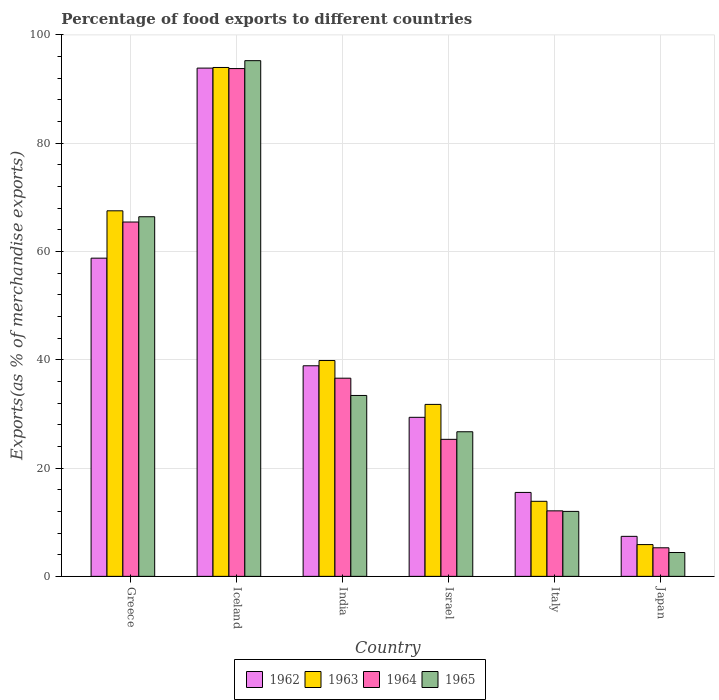How many different coloured bars are there?
Ensure brevity in your answer.  4. Are the number of bars per tick equal to the number of legend labels?
Your answer should be very brief. Yes. Are the number of bars on each tick of the X-axis equal?
Keep it short and to the point. Yes. How many bars are there on the 1st tick from the left?
Make the answer very short. 4. What is the percentage of exports to different countries in 1963 in Greece?
Make the answer very short. 67.52. Across all countries, what is the maximum percentage of exports to different countries in 1964?
Make the answer very short. 93.79. Across all countries, what is the minimum percentage of exports to different countries in 1963?
Make the answer very short. 5.87. In which country was the percentage of exports to different countries in 1962 maximum?
Provide a short and direct response. Iceland. What is the total percentage of exports to different countries in 1964 in the graph?
Provide a short and direct response. 238.53. What is the difference between the percentage of exports to different countries in 1962 in Italy and that in Japan?
Keep it short and to the point. 8.11. What is the difference between the percentage of exports to different countries in 1962 in Iceland and the percentage of exports to different countries in 1964 in Italy?
Your answer should be compact. 81.78. What is the average percentage of exports to different countries in 1962 per country?
Make the answer very short. 40.63. What is the difference between the percentage of exports to different countries of/in 1962 and percentage of exports to different countries of/in 1964 in Greece?
Provide a short and direct response. -6.67. What is the ratio of the percentage of exports to different countries in 1962 in Greece to that in Iceland?
Make the answer very short. 0.63. Is the percentage of exports to different countries in 1965 in Iceland less than that in India?
Offer a very short reply. No. Is the difference between the percentage of exports to different countries in 1962 in Greece and Japan greater than the difference between the percentage of exports to different countries in 1964 in Greece and Japan?
Make the answer very short. No. What is the difference between the highest and the second highest percentage of exports to different countries in 1964?
Give a very brief answer. 28.84. What is the difference between the highest and the lowest percentage of exports to different countries in 1962?
Provide a succinct answer. 86.49. In how many countries, is the percentage of exports to different countries in 1965 greater than the average percentage of exports to different countries in 1965 taken over all countries?
Your answer should be compact. 2. Is the sum of the percentage of exports to different countries in 1965 in Israel and Italy greater than the maximum percentage of exports to different countries in 1963 across all countries?
Offer a very short reply. No. Is it the case that in every country, the sum of the percentage of exports to different countries in 1964 and percentage of exports to different countries in 1962 is greater than the sum of percentage of exports to different countries in 1965 and percentage of exports to different countries in 1963?
Provide a succinct answer. No. What does the 3rd bar from the left in Iceland represents?
Make the answer very short. 1964. What does the 2nd bar from the right in Italy represents?
Your answer should be compact. 1964. Is it the case that in every country, the sum of the percentage of exports to different countries in 1965 and percentage of exports to different countries in 1964 is greater than the percentage of exports to different countries in 1962?
Make the answer very short. Yes. How many bars are there?
Your response must be concise. 24. Are all the bars in the graph horizontal?
Provide a short and direct response. No. How many countries are there in the graph?
Offer a very short reply. 6. Does the graph contain any zero values?
Offer a terse response. No. What is the title of the graph?
Give a very brief answer. Percentage of food exports to different countries. Does "2000" appear as one of the legend labels in the graph?
Ensure brevity in your answer.  No. What is the label or title of the Y-axis?
Your response must be concise. Exports(as % of merchandise exports). What is the Exports(as % of merchandise exports) in 1962 in Greece?
Keep it short and to the point. 58.77. What is the Exports(as % of merchandise exports) of 1963 in Greece?
Your response must be concise. 67.52. What is the Exports(as % of merchandise exports) in 1964 in Greece?
Provide a succinct answer. 65.45. What is the Exports(as % of merchandise exports) in 1965 in Greece?
Keep it short and to the point. 66.42. What is the Exports(as % of merchandise exports) of 1962 in Iceland?
Your response must be concise. 93.87. What is the Exports(as % of merchandise exports) of 1963 in Iceland?
Offer a very short reply. 93.99. What is the Exports(as % of merchandise exports) in 1964 in Iceland?
Offer a terse response. 93.79. What is the Exports(as % of merchandise exports) of 1965 in Iceland?
Keep it short and to the point. 95.25. What is the Exports(as % of merchandise exports) of 1962 in India?
Offer a very short reply. 38.9. What is the Exports(as % of merchandise exports) of 1963 in India?
Offer a terse response. 39.86. What is the Exports(as % of merchandise exports) of 1964 in India?
Give a very brief answer. 36.6. What is the Exports(as % of merchandise exports) of 1965 in India?
Give a very brief answer. 33.41. What is the Exports(as % of merchandise exports) in 1962 in Israel?
Make the answer very short. 29.37. What is the Exports(as % of merchandise exports) of 1963 in Israel?
Keep it short and to the point. 31.76. What is the Exports(as % of merchandise exports) in 1964 in Israel?
Offer a terse response. 25.31. What is the Exports(as % of merchandise exports) in 1965 in Israel?
Your answer should be compact. 26.71. What is the Exports(as % of merchandise exports) of 1962 in Italy?
Provide a succinct answer. 15.5. What is the Exports(as % of merchandise exports) in 1963 in Italy?
Make the answer very short. 13.86. What is the Exports(as % of merchandise exports) of 1964 in Italy?
Give a very brief answer. 12.1. What is the Exports(as % of merchandise exports) in 1965 in Italy?
Give a very brief answer. 12. What is the Exports(as % of merchandise exports) in 1962 in Japan?
Make the answer very short. 7.39. What is the Exports(as % of merchandise exports) in 1963 in Japan?
Provide a succinct answer. 5.87. What is the Exports(as % of merchandise exports) of 1964 in Japan?
Your response must be concise. 5.28. What is the Exports(as % of merchandise exports) of 1965 in Japan?
Provide a short and direct response. 4.41. Across all countries, what is the maximum Exports(as % of merchandise exports) in 1962?
Your answer should be compact. 93.87. Across all countries, what is the maximum Exports(as % of merchandise exports) in 1963?
Make the answer very short. 93.99. Across all countries, what is the maximum Exports(as % of merchandise exports) in 1964?
Offer a very short reply. 93.79. Across all countries, what is the maximum Exports(as % of merchandise exports) of 1965?
Your response must be concise. 95.25. Across all countries, what is the minimum Exports(as % of merchandise exports) in 1962?
Give a very brief answer. 7.39. Across all countries, what is the minimum Exports(as % of merchandise exports) of 1963?
Provide a short and direct response. 5.87. Across all countries, what is the minimum Exports(as % of merchandise exports) of 1964?
Your answer should be compact. 5.28. Across all countries, what is the minimum Exports(as % of merchandise exports) in 1965?
Your answer should be very brief. 4.41. What is the total Exports(as % of merchandise exports) in 1962 in the graph?
Keep it short and to the point. 243.81. What is the total Exports(as % of merchandise exports) in 1963 in the graph?
Keep it short and to the point. 252.87. What is the total Exports(as % of merchandise exports) of 1964 in the graph?
Your answer should be compact. 238.53. What is the total Exports(as % of merchandise exports) of 1965 in the graph?
Give a very brief answer. 238.2. What is the difference between the Exports(as % of merchandise exports) of 1962 in Greece and that in Iceland?
Offer a very short reply. -35.1. What is the difference between the Exports(as % of merchandise exports) in 1963 in Greece and that in Iceland?
Give a very brief answer. -26.47. What is the difference between the Exports(as % of merchandise exports) of 1964 in Greece and that in Iceland?
Offer a very short reply. -28.35. What is the difference between the Exports(as % of merchandise exports) of 1965 in Greece and that in Iceland?
Provide a short and direct response. -28.83. What is the difference between the Exports(as % of merchandise exports) of 1962 in Greece and that in India?
Provide a short and direct response. 19.87. What is the difference between the Exports(as % of merchandise exports) of 1963 in Greece and that in India?
Your response must be concise. 27.65. What is the difference between the Exports(as % of merchandise exports) in 1964 in Greece and that in India?
Offer a very short reply. 28.84. What is the difference between the Exports(as % of merchandise exports) of 1965 in Greece and that in India?
Give a very brief answer. 33.01. What is the difference between the Exports(as % of merchandise exports) in 1962 in Greece and that in Israel?
Your response must be concise. 29.4. What is the difference between the Exports(as % of merchandise exports) in 1963 in Greece and that in Israel?
Offer a terse response. 35.76. What is the difference between the Exports(as % of merchandise exports) in 1964 in Greece and that in Israel?
Give a very brief answer. 40.14. What is the difference between the Exports(as % of merchandise exports) of 1965 in Greece and that in Israel?
Make the answer very short. 39.71. What is the difference between the Exports(as % of merchandise exports) in 1962 in Greece and that in Italy?
Your response must be concise. 43.27. What is the difference between the Exports(as % of merchandise exports) in 1963 in Greece and that in Italy?
Keep it short and to the point. 53.65. What is the difference between the Exports(as % of merchandise exports) in 1964 in Greece and that in Italy?
Provide a succinct answer. 53.35. What is the difference between the Exports(as % of merchandise exports) in 1965 in Greece and that in Italy?
Your answer should be compact. 54.42. What is the difference between the Exports(as % of merchandise exports) in 1962 in Greece and that in Japan?
Provide a short and direct response. 51.38. What is the difference between the Exports(as % of merchandise exports) in 1963 in Greece and that in Japan?
Provide a short and direct response. 61.65. What is the difference between the Exports(as % of merchandise exports) in 1964 in Greece and that in Japan?
Offer a very short reply. 60.17. What is the difference between the Exports(as % of merchandise exports) in 1965 in Greece and that in Japan?
Provide a short and direct response. 62.01. What is the difference between the Exports(as % of merchandise exports) of 1962 in Iceland and that in India?
Keep it short and to the point. 54.98. What is the difference between the Exports(as % of merchandise exports) of 1963 in Iceland and that in India?
Offer a terse response. 54.13. What is the difference between the Exports(as % of merchandise exports) in 1964 in Iceland and that in India?
Your answer should be very brief. 57.19. What is the difference between the Exports(as % of merchandise exports) in 1965 in Iceland and that in India?
Provide a succinct answer. 61.84. What is the difference between the Exports(as % of merchandise exports) of 1962 in Iceland and that in Israel?
Provide a succinct answer. 64.5. What is the difference between the Exports(as % of merchandise exports) in 1963 in Iceland and that in Israel?
Give a very brief answer. 62.23. What is the difference between the Exports(as % of merchandise exports) of 1964 in Iceland and that in Israel?
Offer a terse response. 68.48. What is the difference between the Exports(as % of merchandise exports) of 1965 in Iceland and that in Israel?
Your answer should be compact. 68.54. What is the difference between the Exports(as % of merchandise exports) in 1962 in Iceland and that in Italy?
Your response must be concise. 78.37. What is the difference between the Exports(as % of merchandise exports) in 1963 in Iceland and that in Italy?
Offer a very short reply. 80.13. What is the difference between the Exports(as % of merchandise exports) in 1964 in Iceland and that in Italy?
Offer a terse response. 81.69. What is the difference between the Exports(as % of merchandise exports) in 1965 in Iceland and that in Italy?
Your answer should be compact. 83.25. What is the difference between the Exports(as % of merchandise exports) of 1962 in Iceland and that in Japan?
Give a very brief answer. 86.49. What is the difference between the Exports(as % of merchandise exports) in 1963 in Iceland and that in Japan?
Make the answer very short. 88.12. What is the difference between the Exports(as % of merchandise exports) in 1964 in Iceland and that in Japan?
Your answer should be very brief. 88.51. What is the difference between the Exports(as % of merchandise exports) of 1965 in Iceland and that in Japan?
Your response must be concise. 90.84. What is the difference between the Exports(as % of merchandise exports) in 1962 in India and that in Israel?
Offer a terse response. 9.52. What is the difference between the Exports(as % of merchandise exports) in 1963 in India and that in Israel?
Ensure brevity in your answer.  8.1. What is the difference between the Exports(as % of merchandise exports) of 1964 in India and that in Israel?
Ensure brevity in your answer.  11.29. What is the difference between the Exports(as % of merchandise exports) in 1965 in India and that in Israel?
Your answer should be compact. 6.71. What is the difference between the Exports(as % of merchandise exports) of 1962 in India and that in Italy?
Your answer should be very brief. 23.39. What is the difference between the Exports(as % of merchandise exports) in 1963 in India and that in Italy?
Make the answer very short. 26. What is the difference between the Exports(as % of merchandise exports) of 1964 in India and that in Italy?
Make the answer very short. 24.5. What is the difference between the Exports(as % of merchandise exports) in 1965 in India and that in Italy?
Make the answer very short. 21.41. What is the difference between the Exports(as % of merchandise exports) in 1962 in India and that in Japan?
Keep it short and to the point. 31.51. What is the difference between the Exports(as % of merchandise exports) in 1963 in India and that in Japan?
Provide a short and direct response. 34. What is the difference between the Exports(as % of merchandise exports) of 1964 in India and that in Japan?
Make the answer very short. 31.32. What is the difference between the Exports(as % of merchandise exports) in 1965 in India and that in Japan?
Give a very brief answer. 29.01. What is the difference between the Exports(as % of merchandise exports) of 1962 in Israel and that in Italy?
Provide a short and direct response. 13.87. What is the difference between the Exports(as % of merchandise exports) of 1963 in Israel and that in Italy?
Keep it short and to the point. 17.9. What is the difference between the Exports(as % of merchandise exports) of 1964 in Israel and that in Italy?
Give a very brief answer. 13.21. What is the difference between the Exports(as % of merchandise exports) of 1965 in Israel and that in Italy?
Give a very brief answer. 14.71. What is the difference between the Exports(as % of merchandise exports) of 1962 in Israel and that in Japan?
Keep it short and to the point. 21.98. What is the difference between the Exports(as % of merchandise exports) of 1963 in Israel and that in Japan?
Your response must be concise. 25.89. What is the difference between the Exports(as % of merchandise exports) of 1964 in Israel and that in Japan?
Ensure brevity in your answer.  20.03. What is the difference between the Exports(as % of merchandise exports) of 1965 in Israel and that in Japan?
Offer a very short reply. 22.3. What is the difference between the Exports(as % of merchandise exports) in 1962 in Italy and that in Japan?
Keep it short and to the point. 8.11. What is the difference between the Exports(as % of merchandise exports) of 1963 in Italy and that in Japan?
Make the answer very short. 8. What is the difference between the Exports(as % of merchandise exports) of 1964 in Italy and that in Japan?
Your response must be concise. 6.82. What is the difference between the Exports(as % of merchandise exports) of 1965 in Italy and that in Japan?
Provide a succinct answer. 7.59. What is the difference between the Exports(as % of merchandise exports) in 1962 in Greece and the Exports(as % of merchandise exports) in 1963 in Iceland?
Keep it short and to the point. -35.22. What is the difference between the Exports(as % of merchandise exports) of 1962 in Greece and the Exports(as % of merchandise exports) of 1964 in Iceland?
Your response must be concise. -35.02. What is the difference between the Exports(as % of merchandise exports) of 1962 in Greece and the Exports(as % of merchandise exports) of 1965 in Iceland?
Give a very brief answer. -36.48. What is the difference between the Exports(as % of merchandise exports) in 1963 in Greece and the Exports(as % of merchandise exports) in 1964 in Iceland?
Make the answer very short. -26.27. What is the difference between the Exports(as % of merchandise exports) of 1963 in Greece and the Exports(as % of merchandise exports) of 1965 in Iceland?
Make the answer very short. -27.73. What is the difference between the Exports(as % of merchandise exports) of 1964 in Greece and the Exports(as % of merchandise exports) of 1965 in Iceland?
Make the answer very short. -29.8. What is the difference between the Exports(as % of merchandise exports) in 1962 in Greece and the Exports(as % of merchandise exports) in 1963 in India?
Offer a very short reply. 18.91. What is the difference between the Exports(as % of merchandise exports) of 1962 in Greece and the Exports(as % of merchandise exports) of 1964 in India?
Provide a succinct answer. 22.17. What is the difference between the Exports(as % of merchandise exports) in 1962 in Greece and the Exports(as % of merchandise exports) in 1965 in India?
Your response must be concise. 25.36. What is the difference between the Exports(as % of merchandise exports) of 1963 in Greece and the Exports(as % of merchandise exports) of 1964 in India?
Keep it short and to the point. 30.92. What is the difference between the Exports(as % of merchandise exports) of 1963 in Greece and the Exports(as % of merchandise exports) of 1965 in India?
Your answer should be very brief. 34.1. What is the difference between the Exports(as % of merchandise exports) of 1964 in Greece and the Exports(as % of merchandise exports) of 1965 in India?
Your response must be concise. 32.03. What is the difference between the Exports(as % of merchandise exports) in 1962 in Greece and the Exports(as % of merchandise exports) in 1963 in Israel?
Provide a succinct answer. 27.01. What is the difference between the Exports(as % of merchandise exports) of 1962 in Greece and the Exports(as % of merchandise exports) of 1964 in Israel?
Provide a succinct answer. 33.46. What is the difference between the Exports(as % of merchandise exports) of 1962 in Greece and the Exports(as % of merchandise exports) of 1965 in Israel?
Keep it short and to the point. 32.06. What is the difference between the Exports(as % of merchandise exports) in 1963 in Greece and the Exports(as % of merchandise exports) in 1964 in Israel?
Ensure brevity in your answer.  42.21. What is the difference between the Exports(as % of merchandise exports) of 1963 in Greece and the Exports(as % of merchandise exports) of 1965 in Israel?
Make the answer very short. 40.81. What is the difference between the Exports(as % of merchandise exports) of 1964 in Greece and the Exports(as % of merchandise exports) of 1965 in Israel?
Provide a succinct answer. 38.74. What is the difference between the Exports(as % of merchandise exports) in 1962 in Greece and the Exports(as % of merchandise exports) in 1963 in Italy?
Make the answer very short. 44.91. What is the difference between the Exports(as % of merchandise exports) of 1962 in Greece and the Exports(as % of merchandise exports) of 1964 in Italy?
Ensure brevity in your answer.  46.67. What is the difference between the Exports(as % of merchandise exports) of 1962 in Greece and the Exports(as % of merchandise exports) of 1965 in Italy?
Make the answer very short. 46.77. What is the difference between the Exports(as % of merchandise exports) of 1963 in Greece and the Exports(as % of merchandise exports) of 1964 in Italy?
Offer a terse response. 55.42. What is the difference between the Exports(as % of merchandise exports) of 1963 in Greece and the Exports(as % of merchandise exports) of 1965 in Italy?
Your answer should be very brief. 55.52. What is the difference between the Exports(as % of merchandise exports) in 1964 in Greece and the Exports(as % of merchandise exports) in 1965 in Italy?
Your answer should be very brief. 53.45. What is the difference between the Exports(as % of merchandise exports) in 1962 in Greece and the Exports(as % of merchandise exports) in 1963 in Japan?
Make the answer very short. 52.9. What is the difference between the Exports(as % of merchandise exports) of 1962 in Greece and the Exports(as % of merchandise exports) of 1964 in Japan?
Offer a terse response. 53.49. What is the difference between the Exports(as % of merchandise exports) in 1962 in Greece and the Exports(as % of merchandise exports) in 1965 in Japan?
Give a very brief answer. 54.36. What is the difference between the Exports(as % of merchandise exports) in 1963 in Greece and the Exports(as % of merchandise exports) in 1964 in Japan?
Ensure brevity in your answer.  62.24. What is the difference between the Exports(as % of merchandise exports) in 1963 in Greece and the Exports(as % of merchandise exports) in 1965 in Japan?
Offer a very short reply. 63.11. What is the difference between the Exports(as % of merchandise exports) of 1964 in Greece and the Exports(as % of merchandise exports) of 1965 in Japan?
Ensure brevity in your answer.  61.04. What is the difference between the Exports(as % of merchandise exports) of 1962 in Iceland and the Exports(as % of merchandise exports) of 1963 in India?
Give a very brief answer. 54.01. What is the difference between the Exports(as % of merchandise exports) in 1962 in Iceland and the Exports(as % of merchandise exports) in 1964 in India?
Offer a terse response. 57.27. What is the difference between the Exports(as % of merchandise exports) in 1962 in Iceland and the Exports(as % of merchandise exports) in 1965 in India?
Your response must be concise. 60.46. What is the difference between the Exports(as % of merchandise exports) of 1963 in Iceland and the Exports(as % of merchandise exports) of 1964 in India?
Provide a succinct answer. 57.39. What is the difference between the Exports(as % of merchandise exports) in 1963 in Iceland and the Exports(as % of merchandise exports) in 1965 in India?
Keep it short and to the point. 60.58. What is the difference between the Exports(as % of merchandise exports) of 1964 in Iceland and the Exports(as % of merchandise exports) of 1965 in India?
Ensure brevity in your answer.  60.38. What is the difference between the Exports(as % of merchandise exports) in 1962 in Iceland and the Exports(as % of merchandise exports) in 1963 in Israel?
Offer a very short reply. 62.11. What is the difference between the Exports(as % of merchandise exports) in 1962 in Iceland and the Exports(as % of merchandise exports) in 1964 in Israel?
Ensure brevity in your answer.  68.57. What is the difference between the Exports(as % of merchandise exports) in 1962 in Iceland and the Exports(as % of merchandise exports) in 1965 in Israel?
Provide a succinct answer. 67.17. What is the difference between the Exports(as % of merchandise exports) of 1963 in Iceland and the Exports(as % of merchandise exports) of 1964 in Israel?
Your response must be concise. 68.68. What is the difference between the Exports(as % of merchandise exports) of 1963 in Iceland and the Exports(as % of merchandise exports) of 1965 in Israel?
Your answer should be compact. 67.28. What is the difference between the Exports(as % of merchandise exports) of 1964 in Iceland and the Exports(as % of merchandise exports) of 1965 in Israel?
Give a very brief answer. 67.08. What is the difference between the Exports(as % of merchandise exports) in 1962 in Iceland and the Exports(as % of merchandise exports) in 1963 in Italy?
Offer a very short reply. 80.01. What is the difference between the Exports(as % of merchandise exports) of 1962 in Iceland and the Exports(as % of merchandise exports) of 1964 in Italy?
Give a very brief answer. 81.78. What is the difference between the Exports(as % of merchandise exports) of 1962 in Iceland and the Exports(as % of merchandise exports) of 1965 in Italy?
Make the answer very short. 81.88. What is the difference between the Exports(as % of merchandise exports) of 1963 in Iceland and the Exports(as % of merchandise exports) of 1964 in Italy?
Ensure brevity in your answer.  81.89. What is the difference between the Exports(as % of merchandise exports) in 1963 in Iceland and the Exports(as % of merchandise exports) in 1965 in Italy?
Your answer should be compact. 81.99. What is the difference between the Exports(as % of merchandise exports) of 1964 in Iceland and the Exports(as % of merchandise exports) of 1965 in Italy?
Offer a terse response. 81.79. What is the difference between the Exports(as % of merchandise exports) in 1962 in Iceland and the Exports(as % of merchandise exports) in 1963 in Japan?
Provide a succinct answer. 88.01. What is the difference between the Exports(as % of merchandise exports) in 1962 in Iceland and the Exports(as % of merchandise exports) in 1964 in Japan?
Provide a short and direct response. 88.6. What is the difference between the Exports(as % of merchandise exports) of 1962 in Iceland and the Exports(as % of merchandise exports) of 1965 in Japan?
Keep it short and to the point. 89.47. What is the difference between the Exports(as % of merchandise exports) in 1963 in Iceland and the Exports(as % of merchandise exports) in 1964 in Japan?
Your answer should be very brief. 88.71. What is the difference between the Exports(as % of merchandise exports) in 1963 in Iceland and the Exports(as % of merchandise exports) in 1965 in Japan?
Provide a succinct answer. 89.58. What is the difference between the Exports(as % of merchandise exports) of 1964 in Iceland and the Exports(as % of merchandise exports) of 1965 in Japan?
Your answer should be compact. 89.38. What is the difference between the Exports(as % of merchandise exports) of 1962 in India and the Exports(as % of merchandise exports) of 1963 in Israel?
Offer a terse response. 7.14. What is the difference between the Exports(as % of merchandise exports) in 1962 in India and the Exports(as % of merchandise exports) in 1964 in Israel?
Provide a succinct answer. 13.59. What is the difference between the Exports(as % of merchandise exports) in 1962 in India and the Exports(as % of merchandise exports) in 1965 in Israel?
Ensure brevity in your answer.  12.19. What is the difference between the Exports(as % of merchandise exports) in 1963 in India and the Exports(as % of merchandise exports) in 1964 in Israel?
Keep it short and to the point. 14.56. What is the difference between the Exports(as % of merchandise exports) of 1963 in India and the Exports(as % of merchandise exports) of 1965 in Israel?
Offer a terse response. 13.16. What is the difference between the Exports(as % of merchandise exports) of 1964 in India and the Exports(as % of merchandise exports) of 1965 in Israel?
Offer a terse response. 9.89. What is the difference between the Exports(as % of merchandise exports) of 1962 in India and the Exports(as % of merchandise exports) of 1963 in Italy?
Ensure brevity in your answer.  25.03. What is the difference between the Exports(as % of merchandise exports) of 1962 in India and the Exports(as % of merchandise exports) of 1964 in Italy?
Keep it short and to the point. 26.8. What is the difference between the Exports(as % of merchandise exports) in 1962 in India and the Exports(as % of merchandise exports) in 1965 in Italy?
Offer a terse response. 26.9. What is the difference between the Exports(as % of merchandise exports) of 1963 in India and the Exports(as % of merchandise exports) of 1964 in Italy?
Offer a terse response. 27.77. What is the difference between the Exports(as % of merchandise exports) of 1963 in India and the Exports(as % of merchandise exports) of 1965 in Italy?
Make the answer very short. 27.87. What is the difference between the Exports(as % of merchandise exports) of 1964 in India and the Exports(as % of merchandise exports) of 1965 in Italy?
Give a very brief answer. 24.6. What is the difference between the Exports(as % of merchandise exports) of 1962 in India and the Exports(as % of merchandise exports) of 1963 in Japan?
Give a very brief answer. 33.03. What is the difference between the Exports(as % of merchandise exports) in 1962 in India and the Exports(as % of merchandise exports) in 1964 in Japan?
Offer a terse response. 33.62. What is the difference between the Exports(as % of merchandise exports) of 1962 in India and the Exports(as % of merchandise exports) of 1965 in Japan?
Your answer should be compact. 34.49. What is the difference between the Exports(as % of merchandise exports) in 1963 in India and the Exports(as % of merchandise exports) in 1964 in Japan?
Your answer should be compact. 34.59. What is the difference between the Exports(as % of merchandise exports) in 1963 in India and the Exports(as % of merchandise exports) in 1965 in Japan?
Keep it short and to the point. 35.46. What is the difference between the Exports(as % of merchandise exports) in 1964 in India and the Exports(as % of merchandise exports) in 1965 in Japan?
Provide a succinct answer. 32.2. What is the difference between the Exports(as % of merchandise exports) in 1962 in Israel and the Exports(as % of merchandise exports) in 1963 in Italy?
Offer a terse response. 15.51. What is the difference between the Exports(as % of merchandise exports) in 1962 in Israel and the Exports(as % of merchandise exports) in 1964 in Italy?
Your response must be concise. 17.27. What is the difference between the Exports(as % of merchandise exports) of 1962 in Israel and the Exports(as % of merchandise exports) of 1965 in Italy?
Keep it short and to the point. 17.38. What is the difference between the Exports(as % of merchandise exports) in 1963 in Israel and the Exports(as % of merchandise exports) in 1964 in Italy?
Make the answer very short. 19.66. What is the difference between the Exports(as % of merchandise exports) of 1963 in Israel and the Exports(as % of merchandise exports) of 1965 in Italy?
Offer a very short reply. 19.76. What is the difference between the Exports(as % of merchandise exports) in 1964 in Israel and the Exports(as % of merchandise exports) in 1965 in Italy?
Provide a short and direct response. 13.31. What is the difference between the Exports(as % of merchandise exports) of 1962 in Israel and the Exports(as % of merchandise exports) of 1963 in Japan?
Give a very brief answer. 23.51. What is the difference between the Exports(as % of merchandise exports) in 1962 in Israel and the Exports(as % of merchandise exports) in 1964 in Japan?
Give a very brief answer. 24.1. What is the difference between the Exports(as % of merchandise exports) of 1962 in Israel and the Exports(as % of merchandise exports) of 1965 in Japan?
Provide a short and direct response. 24.97. What is the difference between the Exports(as % of merchandise exports) in 1963 in Israel and the Exports(as % of merchandise exports) in 1964 in Japan?
Ensure brevity in your answer.  26.48. What is the difference between the Exports(as % of merchandise exports) in 1963 in Israel and the Exports(as % of merchandise exports) in 1965 in Japan?
Offer a very short reply. 27.35. What is the difference between the Exports(as % of merchandise exports) of 1964 in Israel and the Exports(as % of merchandise exports) of 1965 in Japan?
Your answer should be compact. 20.9. What is the difference between the Exports(as % of merchandise exports) in 1962 in Italy and the Exports(as % of merchandise exports) in 1963 in Japan?
Keep it short and to the point. 9.63. What is the difference between the Exports(as % of merchandise exports) in 1962 in Italy and the Exports(as % of merchandise exports) in 1964 in Japan?
Make the answer very short. 10.23. What is the difference between the Exports(as % of merchandise exports) of 1962 in Italy and the Exports(as % of merchandise exports) of 1965 in Japan?
Your answer should be very brief. 11.1. What is the difference between the Exports(as % of merchandise exports) of 1963 in Italy and the Exports(as % of merchandise exports) of 1964 in Japan?
Offer a terse response. 8.59. What is the difference between the Exports(as % of merchandise exports) in 1963 in Italy and the Exports(as % of merchandise exports) in 1965 in Japan?
Provide a succinct answer. 9.46. What is the difference between the Exports(as % of merchandise exports) of 1964 in Italy and the Exports(as % of merchandise exports) of 1965 in Japan?
Ensure brevity in your answer.  7.69. What is the average Exports(as % of merchandise exports) of 1962 per country?
Make the answer very short. 40.63. What is the average Exports(as % of merchandise exports) in 1963 per country?
Your answer should be very brief. 42.14. What is the average Exports(as % of merchandise exports) of 1964 per country?
Ensure brevity in your answer.  39.75. What is the average Exports(as % of merchandise exports) in 1965 per country?
Make the answer very short. 39.7. What is the difference between the Exports(as % of merchandise exports) in 1962 and Exports(as % of merchandise exports) in 1963 in Greece?
Your answer should be very brief. -8.75. What is the difference between the Exports(as % of merchandise exports) in 1962 and Exports(as % of merchandise exports) in 1964 in Greece?
Provide a short and direct response. -6.67. What is the difference between the Exports(as % of merchandise exports) in 1962 and Exports(as % of merchandise exports) in 1965 in Greece?
Ensure brevity in your answer.  -7.65. What is the difference between the Exports(as % of merchandise exports) of 1963 and Exports(as % of merchandise exports) of 1964 in Greece?
Provide a short and direct response. 2.07. What is the difference between the Exports(as % of merchandise exports) in 1963 and Exports(as % of merchandise exports) in 1965 in Greece?
Keep it short and to the point. 1.1. What is the difference between the Exports(as % of merchandise exports) of 1964 and Exports(as % of merchandise exports) of 1965 in Greece?
Provide a succinct answer. -0.98. What is the difference between the Exports(as % of merchandise exports) in 1962 and Exports(as % of merchandise exports) in 1963 in Iceland?
Your response must be concise. -0.12. What is the difference between the Exports(as % of merchandise exports) of 1962 and Exports(as % of merchandise exports) of 1964 in Iceland?
Keep it short and to the point. 0.08. What is the difference between the Exports(as % of merchandise exports) of 1962 and Exports(as % of merchandise exports) of 1965 in Iceland?
Your response must be concise. -1.38. What is the difference between the Exports(as % of merchandise exports) in 1963 and Exports(as % of merchandise exports) in 1965 in Iceland?
Your response must be concise. -1.26. What is the difference between the Exports(as % of merchandise exports) of 1964 and Exports(as % of merchandise exports) of 1965 in Iceland?
Your answer should be compact. -1.46. What is the difference between the Exports(as % of merchandise exports) in 1962 and Exports(as % of merchandise exports) in 1963 in India?
Keep it short and to the point. -0.97. What is the difference between the Exports(as % of merchandise exports) of 1962 and Exports(as % of merchandise exports) of 1964 in India?
Keep it short and to the point. 2.29. What is the difference between the Exports(as % of merchandise exports) of 1962 and Exports(as % of merchandise exports) of 1965 in India?
Give a very brief answer. 5.48. What is the difference between the Exports(as % of merchandise exports) in 1963 and Exports(as % of merchandise exports) in 1964 in India?
Your answer should be very brief. 3.26. What is the difference between the Exports(as % of merchandise exports) in 1963 and Exports(as % of merchandise exports) in 1965 in India?
Offer a very short reply. 6.45. What is the difference between the Exports(as % of merchandise exports) of 1964 and Exports(as % of merchandise exports) of 1965 in India?
Make the answer very short. 3.19. What is the difference between the Exports(as % of merchandise exports) of 1962 and Exports(as % of merchandise exports) of 1963 in Israel?
Provide a succinct answer. -2.39. What is the difference between the Exports(as % of merchandise exports) of 1962 and Exports(as % of merchandise exports) of 1964 in Israel?
Ensure brevity in your answer.  4.07. What is the difference between the Exports(as % of merchandise exports) of 1962 and Exports(as % of merchandise exports) of 1965 in Israel?
Give a very brief answer. 2.67. What is the difference between the Exports(as % of merchandise exports) in 1963 and Exports(as % of merchandise exports) in 1964 in Israel?
Keep it short and to the point. 6.45. What is the difference between the Exports(as % of merchandise exports) of 1963 and Exports(as % of merchandise exports) of 1965 in Israel?
Ensure brevity in your answer.  5.05. What is the difference between the Exports(as % of merchandise exports) of 1964 and Exports(as % of merchandise exports) of 1965 in Israel?
Offer a very short reply. -1.4. What is the difference between the Exports(as % of merchandise exports) in 1962 and Exports(as % of merchandise exports) in 1963 in Italy?
Your answer should be very brief. 1.64. What is the difference between the Exports(as % of merchandise exports) of 1962 and Exports(as % of merchandise exports) of 1964 in Italy?
Provide a short and direct response. 3.4. What is the difference between the Exports(as % of merchandise exports) in 1962 and Exports(as % of merchandise exports) in 1965 in Italy?
Make the answer very short. 3.5. What is the difference between the Exports(as % of merchandise exports) of 1963 and Exports(as % of merchandise exports) of 1964 in Italy?
Offer a terse response. 1.77. What is the difference between the Exports(as % of merchandise exports) in 1963 and Exports(as % of merchandise exports) in 1965 in Italy?
Offer a very short reply. 1.87. What is the difference between the Exports(as % of merchandise exports) in 1964 and Exports(as % of merchandise exports) in 1965 in Italy?
Your answer should be very brief. 0.1. What is the difference between the Exports(as % of merchandise exports) of 1962 and Exports(as % of merchandise exports) of 1963 in Japan?
Keep it short and to the point. 1.52. What is the difference between the Exports(as % of merchandise exports) of 1962 and Exports(as % of merchandise exports) of 1964 in Japan?
Offer a very short reply. 2.11. What is the difference between the Exports(as % of merchandise exports) of 1962 and Exports(as % of merchandise exports) of 1965 in Japan?
Make the answer very short. 2.98. What is the difference between the Exports(as % of merchandise exports) of 1963 and Exports(as % of merchandise exports) of 1964 in Japan?
Give a very brief answer. 0.59. What is the difference between the Exports(as % of merchandise exports) of 1963 and Exports(as % of merchandise exports) of 1965 in Japan?
Your response must be concise. 1.46. What is the difference between the Exports(as % of merchandise exports) of 1964 and Exports(as % of merchandise exports) of 1965 in Japan?
Keep it short and to the point. 0.87. What is the ratio of the Exports(as % of merchandise exports) in 1962 in Greece to that in Iceland?
Your answer should be very brief. 0.63. What is the ratio of the Exports(as % of merchandise exports) of 1963 in Greece to that in Iceland?
Keep it short and to the point. 0.72. What is the ratio of the Exports(as % of merchandise exports) in 1964 in Greece to that in Iceland?
Give a very brief answer. 0.7. What is the ratio of the Exports(as % of merchandise exports) of 1965 in Greece to that in Iceland?
Your answer should be compact. 0.7. What is the ratio of the Exports(as % of merchandise exports) of 1962 in Greece to that in India?
Provide a succinct answer. 1.51. What is the ratio of the Exports(as % of merchandise exports) in 1963 in Greece to that in India?
Give a very brief answer. 1.69. What is the ratio of the Exports(as % of merchandise exports) in 1964 in Greece to that in India?
Your response must be concise. 1.79. What is the ratio of the Exports(as % of merchandise exports) of 1965 in Greece to that in India?
Your response must be concise. 1.99. What is the ratio of the Exports(as % of merchandise exports) of 1962 in Greece to that in Israel?
Keep it short and to the point. 2. What is the ratio of the Exports(as % of merchandise exports) of 1963 in Greece to that in Israel?
Provide a succinct answer. 2.13. What is the ratio of the Exports(as % of merchandise exports) of 1964 in Greece to that in Israel?
Give a very brief answer. 2.59. What is the ratio of the Exports(as % of merchandise exports) in 1965 in Greece to that in Israel?
Keep it short and to the point. 2.49. What is the ratio of the Exports(as % of merchandise exports) of 1962 in Greece to that in Italy?
Give a very brief answer. 3.79. What is the ratio of the Exports(as % of merchandise exports) of 1963 in Greece to that in Italy?
Ensure brevity in your answer.  4.87. What is the ratio of the Exports(as % of merchandise exports) in 1964 in Greece to that in Italy?
Your answer should be compact. 5.41. What is the ratio of the Exports(as % of merchandise exports) in 1965 in Greece to that in Italy?
Ensure brevity in your answer.  5.54. What is the ratio of the Exports(as % of merchandise exports) of 1962 in Greece to that in Japan?
Your answer should be very brief. 7.95. What is the ratio of the Exports(as % of merchandise exports) in 1963 in Greece to that in Japan?
Offer a very short reply. 11.5. What is the ratio of the Exports(as % of merchandise exports) of 1964 in Greece to that in Japan?
Offer a terse response. 12.4. What is the ratio of the Exports(as % of merchandise exports) of 1965 in Greece to that in Japan?
Ensure brevity in your answer.  15.07. What is the ratio of the Exports(as % of merchandise exports) of 1962 in Iceland to that in India?
Offer a terse response. 2.41. What is the ratio of the Exports(as % of merchandise exports) in 1963 in Iceland to that in India?
Your answer should be compact. 2.36. What is the ratio of the Exports(as % of merchandise exports) in 1964 in Iceland to that in India?
Your answer should be very brief. 2.56. What is the ratio of the Exports(as % of merchandise exports) in 1965 in Iceland to that in India?
Your response must be concise. 2.85. What is the ratio of the Exports(as % of merchandise exports) in 1962 in Iceland to that in Israel?
Your answer should be very brief. 3.2. What is the ratio of the Exports(as % of merchandise exports) of 1963 in Iceland to that in Israel?
Provide a succinct answer. 2.96. What is the ratio of the Exports(as % of merchandise exports) of 1964 in Iceland to that in Israel?
Offer a very short reply. 3.71. What is the ratio of the Exports(as % of merchandise exports) of 1965 in Iceland to that in Israel?
Offer a very short reply. 3.57. What is the ratio of the Exports(as % of merchandise exports) of 1962 in Iceland to that in Italy?
Offer a very short reply. 6.05. What is the ratio of the Exports(as % of merchandise exports) of 1963 in Iceland to that in Italy?
Offer a terse response. 6.78. What is the ratio of the Exports(as % of merchandise exports) in 1964 in Iceland to that in Italy?
Your answer should be very brief. 7.75. What is the ratio of the Exports(as % of merchandise exports) of 1965 in Iceland to that in Italy?
Ensure brevity in your answer.  7.94. What is the ratio of the Exports(as % of merchandise exports) in 1962 in Iceland to that in Japan?
Your answer should be compact. 12.7. What is the ratio of the Exports(as % of merchandise exports) of 1963 in Iceland to that in Japan?
Keep it short and to the point. 16.01. What is the ratio of the Exports(as % of merchandise exports) in 1964 in Iceland to that in Japan?
Offer a terse response. 17.77. What is the ratio of the Exports(as % of merchandise exports) of 1965 in Iceland to that in Japan?
Your answer should be very brief. 21.62. What is the ratio of the Exports(as % of merchandise exports) of 1962 in India to that in Israel?
Ensure brevity in your answer.  1.32. What is the ratio of the Exports(as % of merchandise exports) in 1963 in India to that in Israel?
Provide a succinct answer. 1.26. What is the ratio of the Exports(as % of merchandise exports) of 1964 in India to that in Israel?
Your response must be concise. 1.45. What is the ratio of the Exports(as % of merchandise exports) of 1965 in India to that in Israel?
Keep it short and to the point. 1.25. What is the ratio of the Exports(as % of merchandise exports) in 1962 in India to that in Italy?
Your answer should be very brief. 2.51. What is the ratio of the Exports(as % of merchandise exports) in 1963 in India to that in Italy?
Your answer should be very brief. 2.88. What is the ratio of the Exports(as % of merchandise exports) in 1964 in India to that in Italy?
Provide a succinct answer. 3.03. What is the ratio of the Exports(as % of merchandise exports) of 1965 in India to that in Italy?
Your response must be concise. 2.78. What is the ratio of the Exports(as % of merchandise exports) in 1962 in India to that in Japan?
Offer a terse response. 5.26. What is the ratio of the Exports(as % of merchandise exports) of 1963 in India to that in Japan?
Provide a short and direct response. 6.79. What is the ratio of the Exports(as % of merchandise exports) in 1964 in India to that in Japan?
Provide a short and direct response. 6.93. What is the ratio of the Exports(as % of merchandise exports) in 1965 in India to that in Japan?
Your response must be concise. 7.58. What is the ratio of the Exports(as % of merchandise exports) of 1962 in Israel to that in Italy?
Offer a very short reply. 1.89. What is the ratio of the Exports(as % of merchandise exports) in 1963 in Israel to that in Italy?
Your answer should be compact. 2.29. What is the ratio of the Exports(as % of merchandise exports) in 1964 in Israel to that in Italy?
Provide a short and direct response. 2.09. What is the ratio of the Exports(as % of merchandise exports) in 1965 in Israel to that in Italy?
Offer a terse response. 2.23. What is the ratio of the Exports(as % of merchandise exports) in 1962 in Israel to that in Japan?
Your answer should be very brief. 3.98. What is the ratio of the Exports(as % of merchandise exports) in 1963 in Israel to that in Japan?
Provide a short and direct response. 5.41. What is the ratio of the Exports(as % of merchandise exports) of 1964 in Israel to that in Japan?
Give a very brief answer. 4.79. What is the ratio of the Exports(as % of merchandise exports) of 1965 in Israel to that in Japan?
Offer a terse response. 6.06. What is the ratio of the Exports(as % of merchandise exports) of 1962 in Italy to that in Japan?
Ensure brevity in your answer.  2.1. What is the ratio of the Exports(as % of merchandise exports) in 1963 in Italy to that in Japan?
Your answer should be very brief. 2.36. What is the ratio of the Exports(as % of merchandise exports) of 1964 in Italy to that in Japan?
Your response must be concise. 2.29. What is the ratio of the Exports(as % of merchandise exports) of 1965 in Italy to that in Japan?
Keep it short and to the point. 2.72. What is the difference between the highest and the second highest Exports(as % of merchandise exports) in 1962?
Keep it short and to the point. 35.1. What is the difference between the highest and the second highest Exports(as % of merchandise exports) of 1963?
Your answer should be compact. 26.47. What is the difference between the highest and the second highest Exports(as % of merchandise exports) in 1964?
Your response must be concise. 28.35. What is the difference between the highest and the second highest Exports(as % of merchandise exports) in 1965?
Ensure brevity in your answer.  28.83. What is the difference between the highest and the lowest Exports(as % of merchandise exports) of 1962?
Make the answer very short. 86.49. What is the difference between the highest and the lowest Exports(as % of merchandise exports) of 1963?
Keep it short and to the point. 88.12. What is the difference between the highest and the lowest Exports(as % of merchandise exports) in 1964?
Give a very brief answer. 88.51. What is the difference between the highest and the lowest Exports(as % of merchandise exports) of 1965?
Your response must be concise. 90.84. 